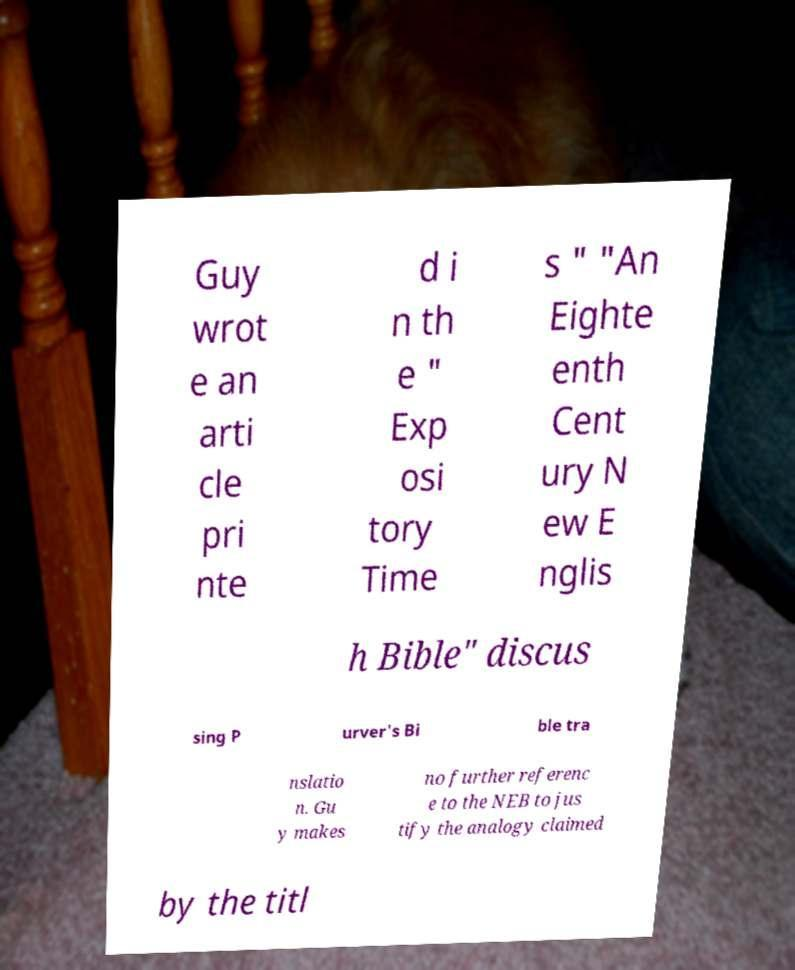Could you assist in decoding the text presented in this image and type it out clearly? Guy wrot e an arti cle pri nte d i n th e " Exp osi tory Time s " "An Eighte enth Cent ury N ew E nglis h Bible" discus sing P urver's Bi ble tra nslatio n. Gu y makes no further referenc e to the NEB to jus tify the analogy claimed by the titl 